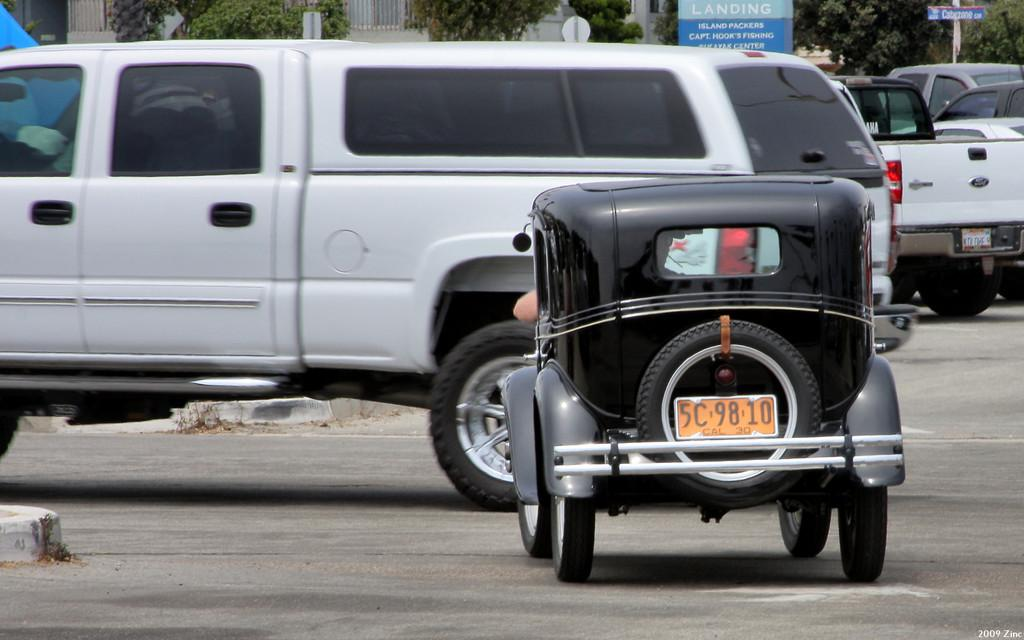What color is the vehicle on the road in the image? There is a black vehicle on the road in the image. Can you describe the other vehicle in the image? There is a white car on the left side of the image. Where is the lock located in the image? There is no lock present in the image. What type of pump can be seen in the image? There is no pump present in the image. 